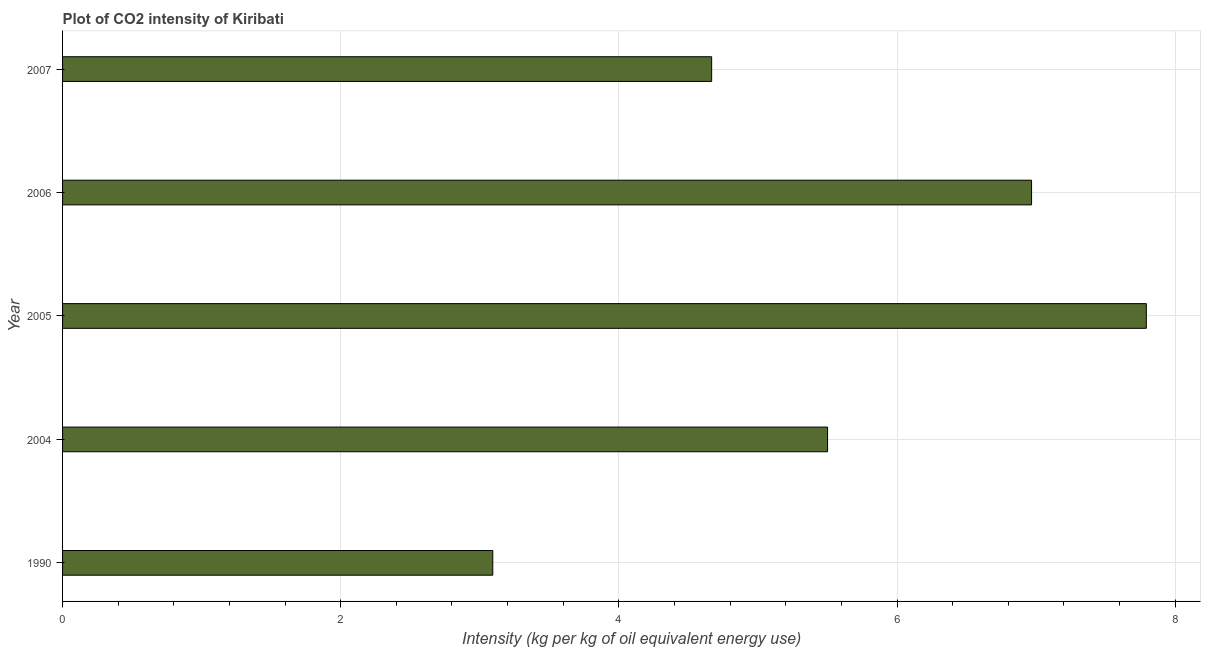Does the graph contain grids?
Provide a succinct answer. Yes. What is the title of the graph?
Keep it short and to the point. Plot of CO2 intensity of Kiribati. What is the label or title of the X-axis?
Offer a terse response. Intensity (kg per kg of oil equivalent energy use). What is the co2 intensity in 2007?
Your answer should be compact. 4.67. Across all years, what is the maximum co2 intensity?
Provide a short and direct response. 7.79. Across all years, what is the minimum co2 intensity?
Give a very brief answer. 3.09. What is the sum of the co2 intensity?
Keep it short and to the point. 28.02. What is the average co2 intensity per year?
Offer a very short reply. 5.6. What is the median co2 intensity?
Offer a terse response. 5.5. What is the ratio of the co2 intensity in 1990 to that in 2006?
Your answer should be very brief. 0.44. Is the difference between the co2 intensity in 2006 and 2007 greater than the difference between any two years?
Your answer should be compact. No. What is the difference between the highest and the second highest co2 intensity?
Offer a very short reply. 0.82. Is the sum of the co2 intensity in 1990 and 2007 greater than the maximum co2 intensity across all years?
Make the answer very short. No. What is the difference between the highest and the lowest co2 intensity?
Your answer should be compact. 4.7. How many years are there in the graph?
Provide a succinct answer. 5. What is the Intensity (kg per kg of oil equivalent energy use) of 1990?
Provide a succinct answer. 3.09. What is the Intensity (kg per kg of oil equivalent energy use) of 2004?
Offer a very short reply. 5.5. What is the Intensity (kg per kg of oil equivalent energy use) of 2005?
Provide a succinct answer. 7.79. What is the Intensity (kg per kg of oil equivalent energy use) of 2006?
Offer a very short reply. 6.97. What is the Intensity (kg per kg of oil equivalent energy use) of 2007?
Give a very brief answer. 4.67. What is the difference between the Intensity (kg per kg of oil equivalent energy use) in 1990 and 2004?
Your answer should be compact. -2.41. What is the difference between the Intensity (kg per kg of oil equivalent energy use) in 1990 and 2005?
Your answer should be very brief. -4.7. What is the difference between the Intensity (kg per kg of oil equivalent energy use) in 1990 and 2006?
Offer a very short reply. -3.87. What is the difference between the Intensity (kg per kg of oil equivalent energy use) in 1990 and 2007?
Your answer should be compact. -1.57. What is the difference between the Intensity (kg per kg of oil equivalent energy use) in 2004 and 2005?
Give a very brief answer. -2.29. What is the difference between the Intensity (kg per kg of oil equivalent energy use) in 2004 and 2006?
Offer a terse response. -1.47. What is the difference between the Intensity (kg per kg of oil equivalent energy use) in 2004 and 2007?
Provide a succinct answer. 0.83. What is the difference between the Intensity (kg per kg of oil equivalent energy use) in 2005 and 2006?
Your response must be concise. 0.83. What is the difference between the Intensity (kg per kg of oil equivalent energy use) in 2005 and 2007?
Provide a short and direct response. 3.13. What is the difference between the Intensity (kg per kg of oil equivalent energy use) in 2006 and 2007?
Give a very brief answer. 2.3. What is the ratio of the Intensity (kg per kg of oil equivalent energy use) in 1990 to that in 2004?
Your answer should be very brief. 0.56. What is the ratio of the Intensity (kg per kg of oil equivalent energy use) in 1990 to that in 2005?
Give a very brief answer. 0.4. What is the ratio of the Intensity (kg per kg of oil equivalent energy use) in 1990 to that in 2006?
Your answer should be very brief. 0.44. What is the ratio of the Intensity (kg per kg of oil equivalent energy use) in 1990 to that in 2007?
Give a very brief answer. 0.66. What is the ratio of the Intensity (kg per kg of oil equivalent energy use) in 2004 to that in 2005?
Provide a succinct answer. 0.71. What is the ratio of the Intensity (kg per kg of oil equivalent energy use) in 2004 to that in 2006?
Your answer should be compact. 0.79. What is the ratio of the Intensity (kg per kg of oil equivalent energy use) in 2004 to that in 2007?
Provide a succinct answer. 1.18. What is the ratio of the Intensity (kg per kg of oil equivalent energy use) in 2005 to that in 2006?
Provide a succinct answer. 1.12. What is the ratio of the Intensity (kg per kg of oil equivalent energy use) in 2005 to that in 2007?
Your answer should be compact. 1.67. What is the ratio of the Intensity (kg per kg of oil equivalent energy use) in 2006 to that in 2007?
Provide a short and direct response. 1.49. 